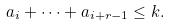Convert formula to latex. <formula><loc_0><loc_0><loc_500><loc_500>a _ { i } + \cdots + a _ { i + r - 1 } \leq k .</formula> 